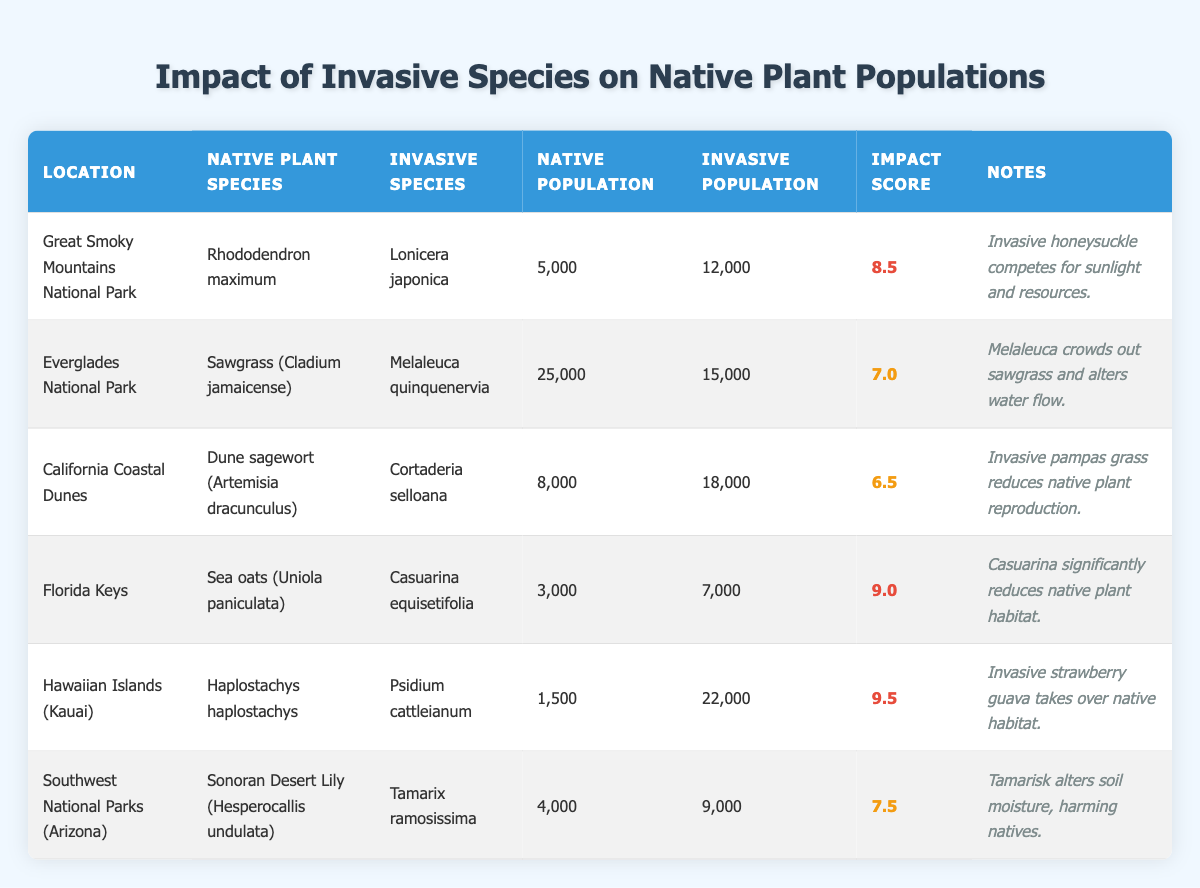What is the impact score for the invasive species in Great Smoky Mountains National Park? The table lists the impact score for the invasive species in Great Smoky Mountains National Park as 8.5.
Answer: 8.5 Is the population estimate of invasive species higher than that of native species in Everglades National Park? The table provides a native population estimate of 25,000 for Sawgrass and an invasive population estimate of 15,000 for Melaleuca. Since 15,000 is less than 25,000, the statement is false.
Answer: No Which location has the highest impact score on native plant populations? By comparing the impact scores in the table, the highest score is 9.5 for Hawaiian Islands (Kauai).
Answer: Hawaiian Islands (Kauai) What is the difference between the invasive and native population estimates for the Sea oats in Florida Keys? The table shows a native population estimate of 3,000 and an invasive estimate of 7,000. The difference is calculated by subtracting 3,000 from 7,000, which equals 4,000.
Answer: 4000 Which invasive species has the lowest impact score, and what is that score? By reviewing the impact scores, Cortaderia selloana in California Coastal Dunes has the lowest impact score of 6.5.
Answer: Cortaderia selloana, 6.5 Is it true that the native population of Dune sagewort is greater than its invasive counterpart? The table indicates that the native population estimate of Dune sagewort is 8,000, and the invasive population estimate is 18,000. Since 8,000 is less than 18,000, the statement is false.
Answer: No How many locations have an impact score of 7.5 or higher? Inspecting the scores, the locations with scores of 7.5 or higher are Great Smoky Mountains National Park (8.5), Florida Keys (9.0), Hawaiian Islands (Kauai) (9.5), and Southwest National Parks (7.5), totaling four locations.
Answer: 4 What is the average native population estimate across all locations listed? To find the average, sum all native populations (5,000 + 25,000 + 8,000 + 3,000 + 1,500 + 4,000 = 46,500) and divide by the number of locations (6), resulting in an average of 7,750.
Answer: 7750 Which invasive species affects the Haplostachys haplostachys in the Hawaiian Islands? The table specifies the invasive species affecting Haplostachys haplostachys in Hawaiian Islands as Psidium cattleianum.
Answer: Psidium cattleianum 